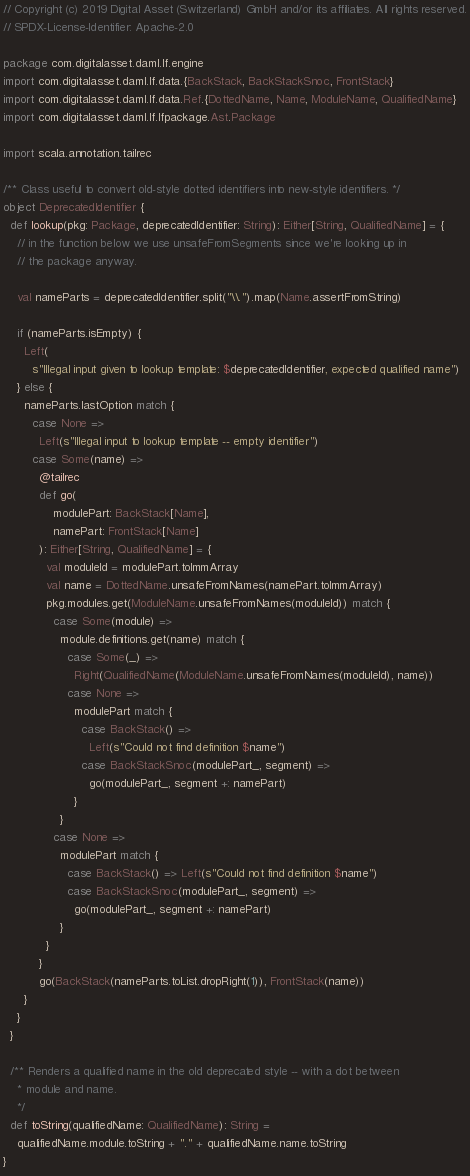Convert code to text. <code><loc_0><loc_0><loc_500><loc_500><_Scala_>// Copyright (c) 2019 Digital Asset (Switzerland) GmbH and/or its affiliates. All rights reserved.
// SPDX-License-Identifier: Apache-2.0

package com.digitalasset.daml.lf.engine
import com.digitalasset.daml.lf.data.{BackStack, BackStackSnoc, FrontStack}
import com.digitalasset.daml.lf.data.Ref.{DottedName, Name, ModuleName, QualifiedName}
import com.digitalasset.daml.lf.lfpackage.Ast.Package

import scala.annotation.tailrec

/** Class useful to convert old-style dotted identifiers into new-style identifiers. */
object DeprecatedIdentifier {
  def lookup(pkg: Package, deprecatedIdentifier: String): Either[String, QualifiedName] = {
    // in the function below we use unsafeFromSegments since we're looking up in
    // the package anyway.

    val nameParts = deprecatedIdentifier.split("\\.").map(Name.assertFromString)

    if (nameParts.isEmpty) {
      Left(
        s"Illegal input given to lookup template: $deprecatedIdentifier, expected qualified name")
    } else {
      nameParts.lastOption match {
        case None =>
          Left(s"Illegal input to lookup template -- empty identifier")
        case Some(name) =>
          @tailrec
          def go(
              modulePart: BackStack[Name],
              namePart: FrontStack[Name]
          ): Either[String, QualifiedName] = {
            val moduleId = modulePart.toImmArray
            val name = DottedName.unsafeFromNames(namePart.toImmArray)
            pkg.modules.get(ModuleName.unsafeFromNames(moduleId)) match {
              case Some(module) =>
                module.definitions.get(name) match {
                  case Some(_) =>
                    Right(QualifiedName(ModuleName.unsafeFromNames(moduleId), name))
                  case None =>
                    modulePart match {
                      case BackStack() =>
                        Left(s"Could not find definition $name")
                      case BackStackSnoc(modulePart_, segment) =>
                        go(modulePart_, segment +: namePart)
                    }
                }
              case None =>
                modulePart match {
                  case BackStack() => Left(s"Could not find definition $name")
                  case BackStackSnoc(modulePart_, segment) =>
                    go(modulePart_, segment +: namePart)
                }
            }
          }
          go(BackStack(nameParts.toList.dropRight(1)), FrontStack(name))
      }
    }
  }

  /** Renders a qualified name in the old deprecated style -- with a dot between
    * module and name.
    */
  def toString(qualifiedName: QualifiedName): String =
    qualifiedName.module.toString + "." + qualifiedName.name.toString
}
</code> 